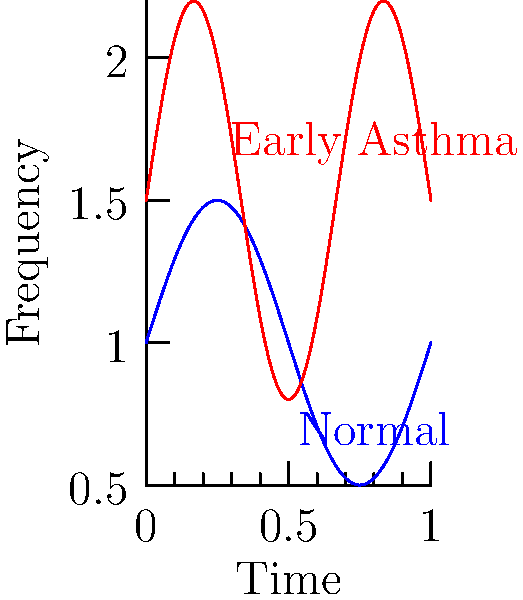Based on the lung sound spectrogram above, which characteristic distinguishes the early signs of an asthma attack from normal breathing? To analyze the lung sound spectrogram and identify early signs of an asthma attack:

1. Observe the two waveforms: blue (normal breathing) and red (early asthma).

2. Compare the amplitude:
   - Normal breathing (blue): lower amplitude, peaks around 1.5
   - Early asthma (red): higher amplitude, peaks around 2.2

3. Examine the frequency:
   - Normal breathing: lower frequency, fewer oscillations
   - Early asthma: higher frequency, more oscillations per unit time

4. Consider the physiological implications:
   - Higher amplitude in asthma indicates increased airflow obstruction
   - Higher frequency suggests wheezing, a common asthma symptom

5. Conclusion: The primary distinguishing characteristic is the combination of higher amplitude and higher frequency in the early asthma waveform.

This analysis is crucial for a college student with severe seasonal allergies, as it can help in early detection and management of potential asthma attacks.
Answer: Higher amplitude and frequency 